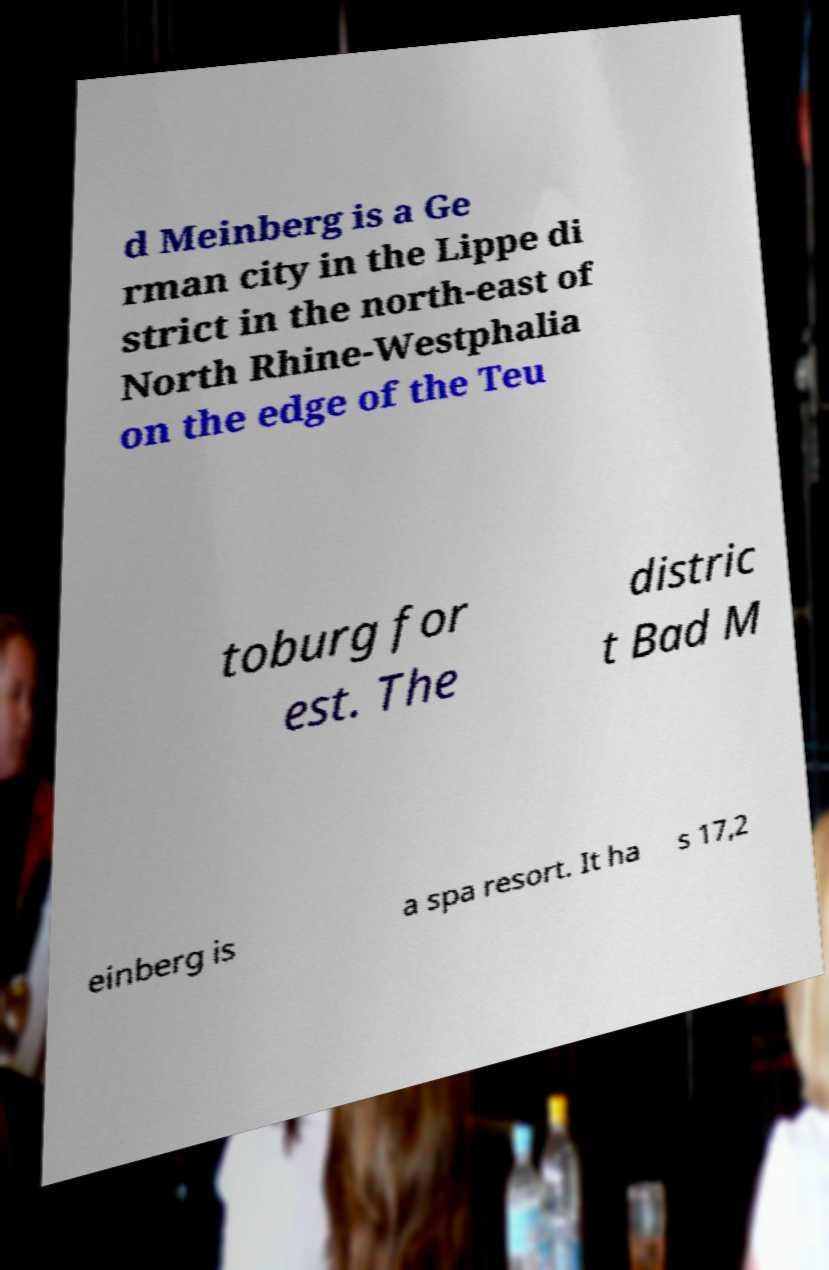What messages or text are displayed in this image? I need them in a readable, typed format. d Meinberg is a Ge rman city in the Lippe di strict in the north-east of North Rhine-Westphalia on the edge of the Teu toburg for est. The distric t Bad M einberg is a spa resort. It ha s 17,2 